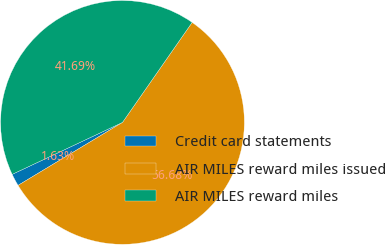Convert chart. <chart><loc_0><loc_0><loc_500><loc_500><pie_chart><fcel>Credit card statements<fcel>AIR MILES reward miles issued<fcel>AIR MILES reward miles<nl><fcel>1.63%<fcel>56.68%<fcel>41.69%<nl></chart> 